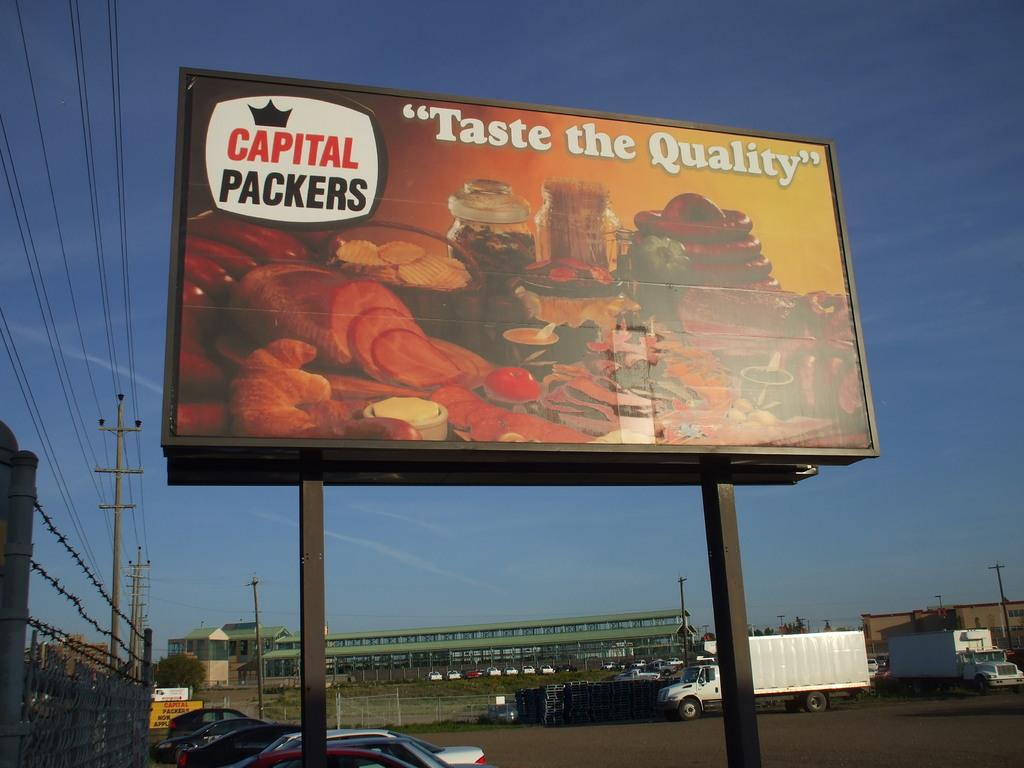<image>
Describe the image concisely. A message that says Taste the Quality sponsored by Capital Packers is on a billboard in a parking lot. 